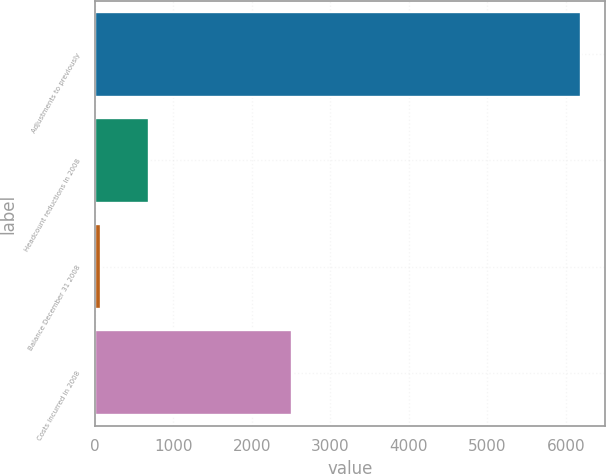<chart> <loc_0><loc_0><loc_500><loc_500><bar_chart><fcel>Adjustments to previously<fcel>Headcount reductions in 2008<fcel>Balance December 31 2008<fcel>Costs incurred in 2008<nl><fcel>6193<fcel>695.8<fcel>85<fcel>2518<nl></chart> 